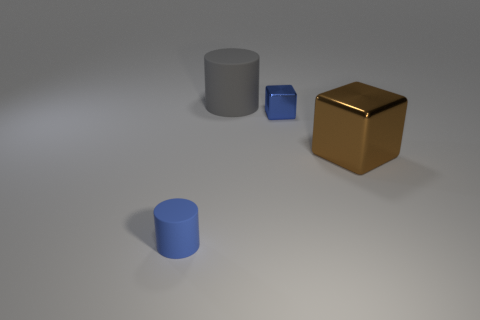Add 1 large brown matte blocks. How many objects exist? 5 Add 2 blue matte things. How many blue matte things exist? 3 Subtract 0 green spheres. How many objects are left? 4 Subtract all yellow cubes. Subtract all matte objects. How many objects are left? 2 Add 4 blue blocks. How many blue blocks are left? 5 